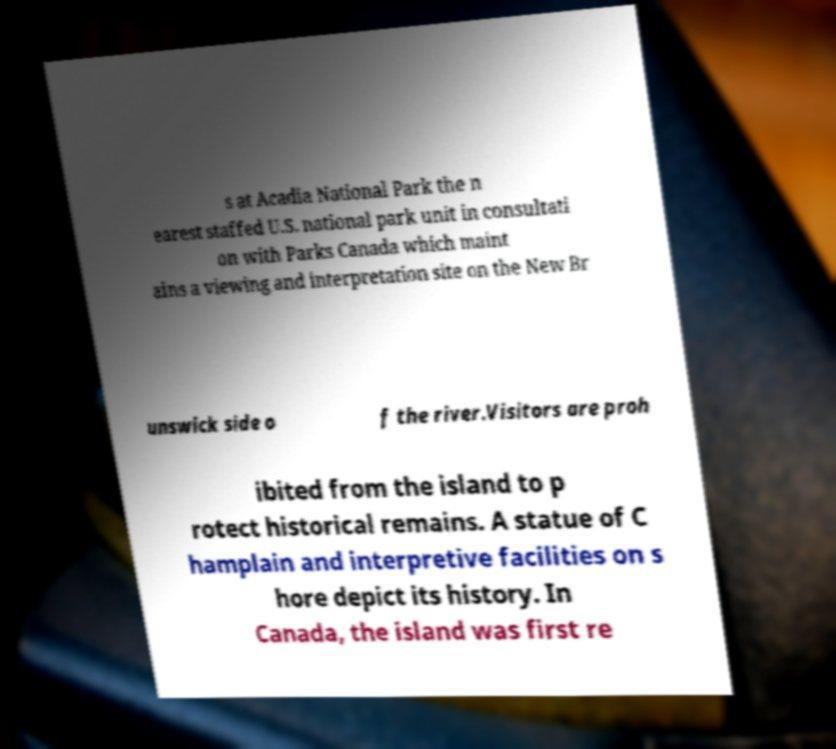Could you extract and type out the text from this image? s at Acadia National Park the n earest staffed U.S. national park unit in consultati on with Parks Canada which maint ains a viewing and interpretation site on the New Br unswick side o f the river.Visitors are proh ibited from the island to p rotect historical remains. A statue of C hamplain and interpretive facilities on s hore depict its history. In Canada, the island was first re 